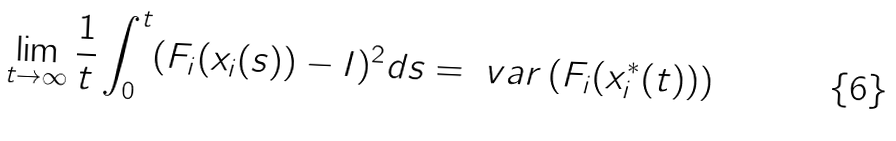<formula> <loc_0><loc_0><loc_500><loc_500>\lim _ { t \to \infty } \frac { 1 } { t } \int _ { 0 } ^ { t } ( F _ { i } ( x _ { i } ( s ) ) - I ) ^ { 2 } d s = \ v a r \left ( F _ { i } ( x _ { i } ^ { * } ( t ) ) \right )</formula> 